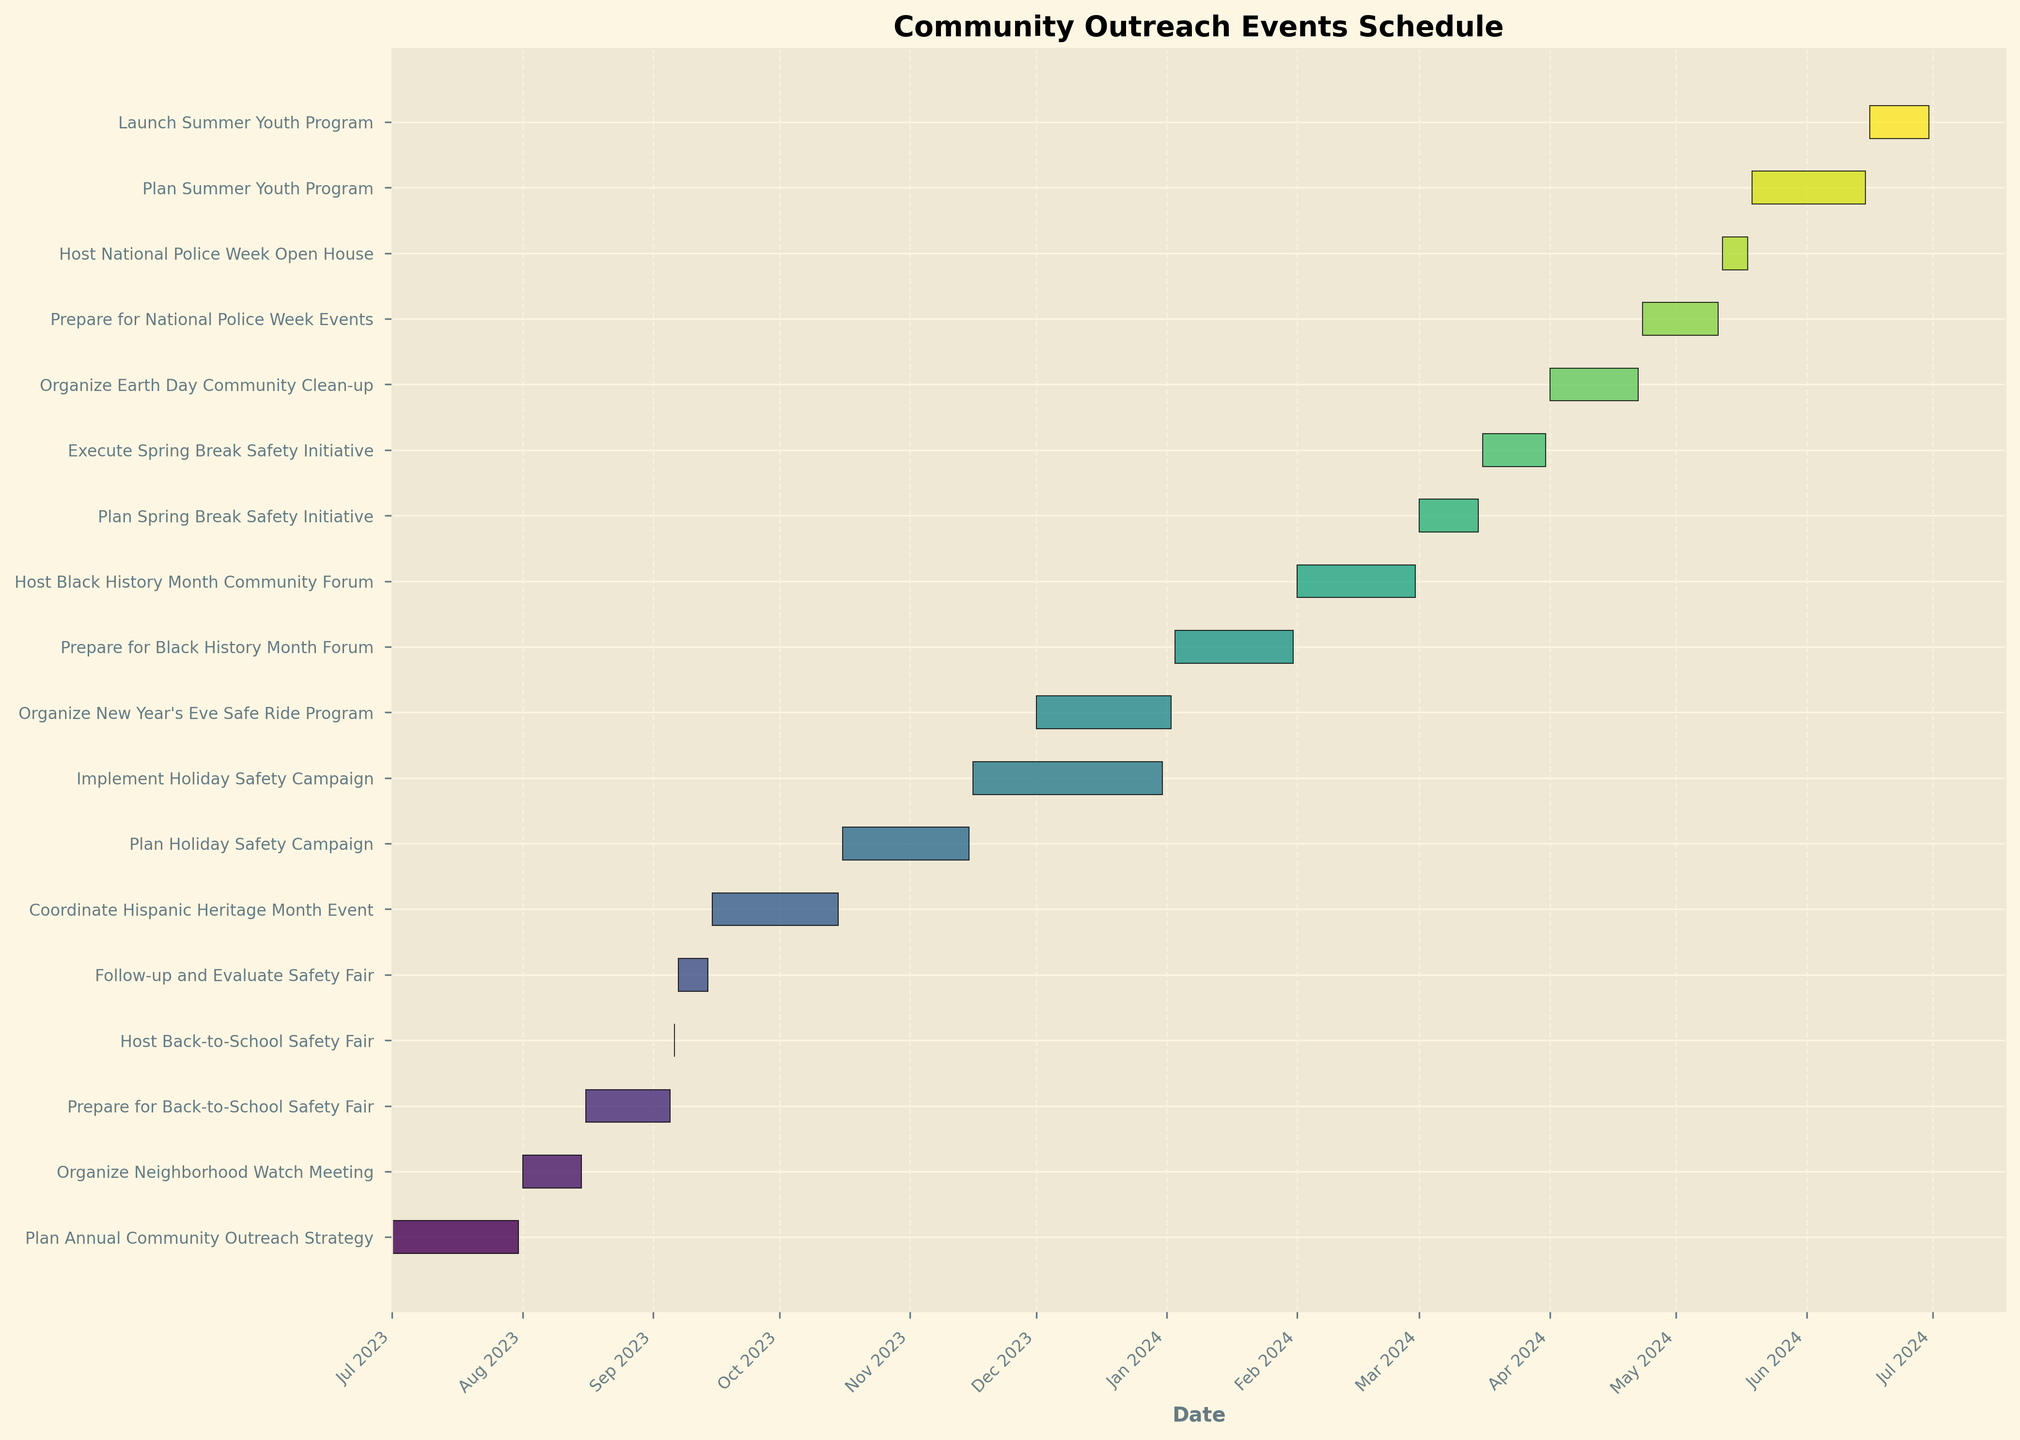What's the title of the chart? The title can be found at the top of the chart, typically in a larger or bolded font. In this case, the title is "Community Outreach Events Schedule".
Answer: Community Outreach Events Schedule How is the time axis labeled? The time axis is the horizontal axis (x-axis) and it is labeled with "Date".
Answer: Date Which event starts first in the fiscal year? By looking at the start dates on the left of each bar, the event that starts first is the "Plan Annual Community Outreach Strategy," which begins on July 1, 2023.
Answer: Plan Annual Community Outreach Strategy What colors are used to differentiate the tasks? The chart uses a gradient of colors from a colormap, likely ranging from lighter to darker shades of a specific color spectrum to differentiate the tasks.
Answer: Gradient of colors How many events are scheduled from September to December 2023? Identify all the events with start and end dates within the given range. This includes:
1. Prepare for Back-to-School Safety Fair
2. Host Back-to-School Safety Fair
3. Follow-up and Evaluate Safety Fair
4. Coordinate Hispanic Heritage Month Event
5. Plan Holiday Safety Campaign
6. Implement Holiday Safety Campaign
7. Organize New Year's Eve Safe Ride Program
Answer: Seven Which event has the shortest duration? The shortest duration is determined by comparing the lengths of the horizontal bars. The "Host Back-to-School Safety Fair" has the shortest duration, as it occurs in a single day.
Answer: Host Back-to-School Safety Fair How many events occur in June 2024? Check the timeline for June 2024 and identify the events that occur during this month:
1. Plan Summer Youth Program
2. Launch Summer Youth Program
Answer: Two How long is the duration of "Coordinate Hispanic Heritage Month Event"? Find the start and end dates for the event. The event begins on September 15, 2023, and ends on October 15, 2023. The duration is the difference between these dates, which is 30 days.
Answer: 30 days What is the total duration of events in October 2023? Identify events in October and sum their durations:
1. Coordinate Hispanic Heritage Month Event (Oct 1 - Oct 15): 15 days
2. Plan Holiday Safety Campaign (Oct 16 - Oct 31): 16 days
Total duration = 15 + 16 = 31 days
Answer: 31 days 